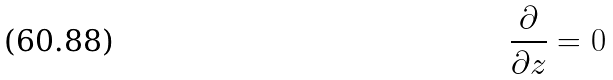Convert formula to latex. <formula><loc_0><loc_0><loc_500><loc_500>\frac { \partial } { \partial z } = 0</formula> 